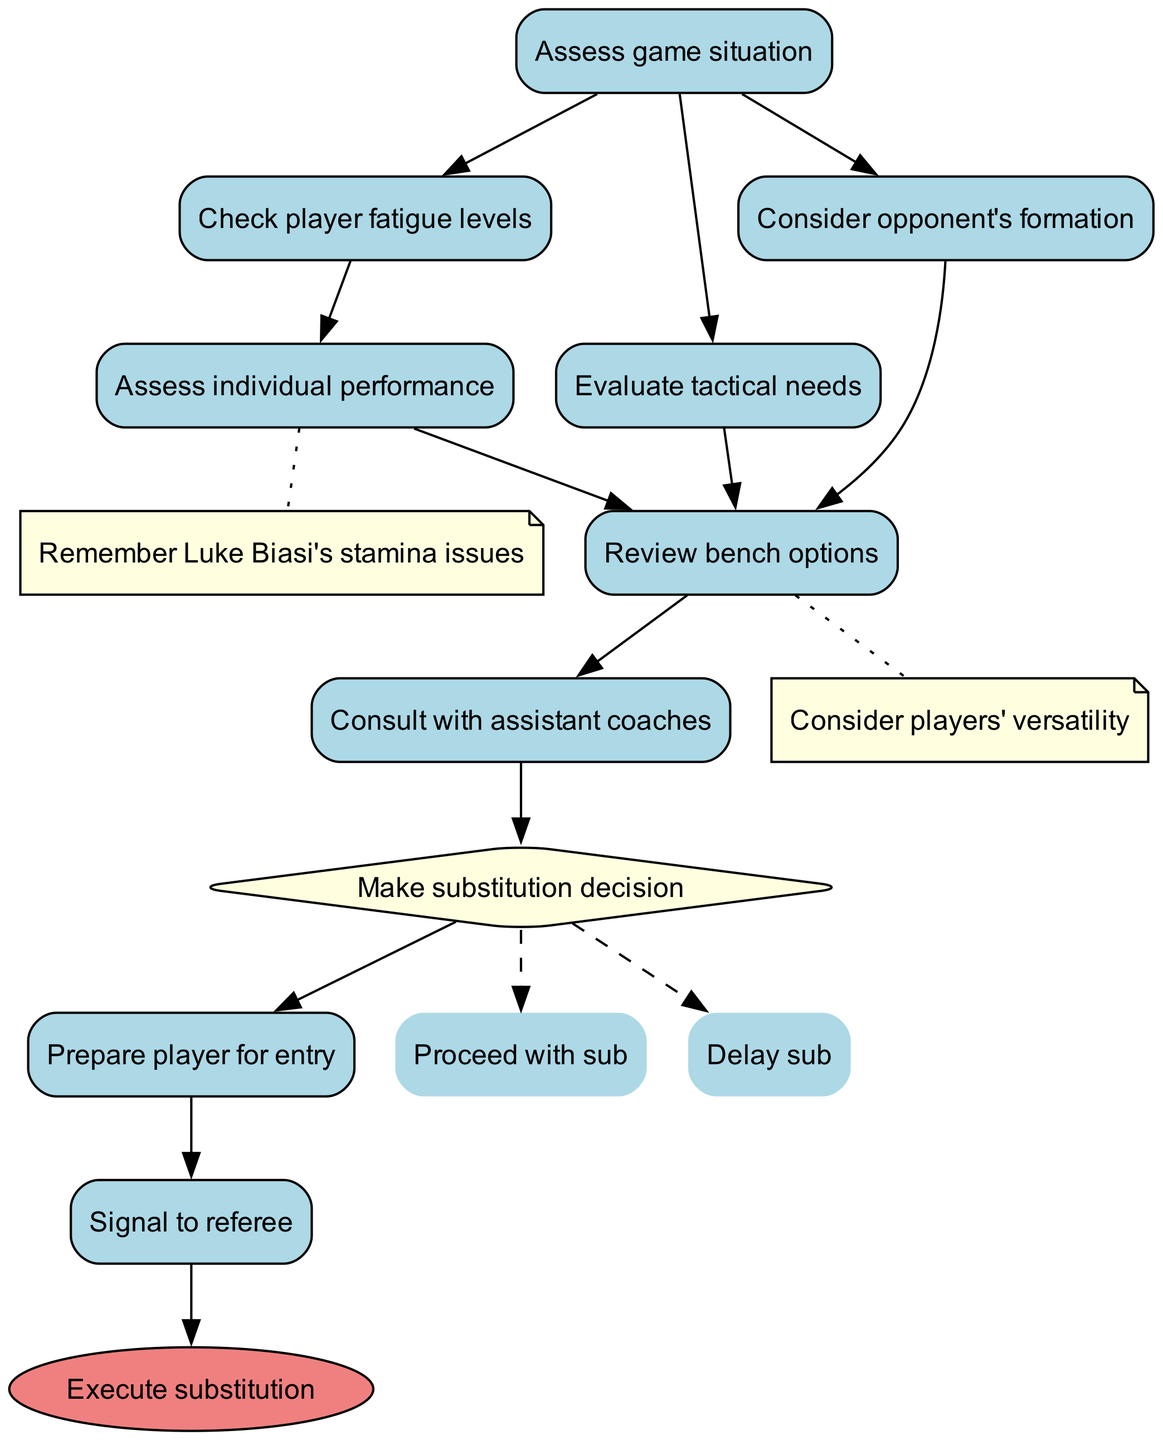What is the starting node of the flowchart? The diagram indicates that the starting node is labeled "Assess game situation". This is the first step in the flowchart from which other nodes branch off.
Answer: Assess game situation How many nodes are present in the flowchart? The diagram lists a total of 10 nodes. This includes all the stages from the beginning to the execution of substitutions, including the start node and each decision and action node.
Answer: 10 What is the last node in the flowchart? The final node reached in the flowchart is "Execute substitution", indicating the completion of the substitution process after all prior steps have been followed.
Answer: Execute substitution Which node follows "Consult with assistant coaches"? The node that directly follows "Consult with assistant coaches" is "Make substitution decision". This indicates that after consulting, a decision regarding making a substitution is made.
Answer: Make substitution decision What is noted about "Assess individual performance"? The note associated with "Assess individual performance" mentions remembering "Luke Biasi's stamina issues". This reflects a specific consideration during player assessments.
Answer: Remember Luke Biasi's stamina issues How many options are available at the "Make substitution decision" node? There are two options available at this node: "Proceed with sub" and "Delay sub". These options provide choices for the substitute decision based on the game's dynamics.
Answer: 2 What kind of edge follows the "Prepare player for entry" node? The edge following "Prepare player for entry" leads to "Signal to referee", indicating that signaling is the next step after preparing the player.
Answer: Signal to referee Which node is shaped as a diamond in the flowchart? The node shaped as a diamond is "Make substitution decision". This shape typically indicates a point in the process where a decision must be made.
Answer: Make substitution decision What is the relationship between "Check player fatigue levels" and "Assess individual performance"? The relationship is that "Check player fatigue levels" must be completed before moving on to "Assess individual performance". This sequential flow shows that fatigue needs assessing first.
Answer: Sequential flow What is the note regarding "Review bench options"? The note states to "Consider players' versatility". This implies that when reviewing bench options, the versatility of available players should be an important factor.
Answer: Consider players' versatility 